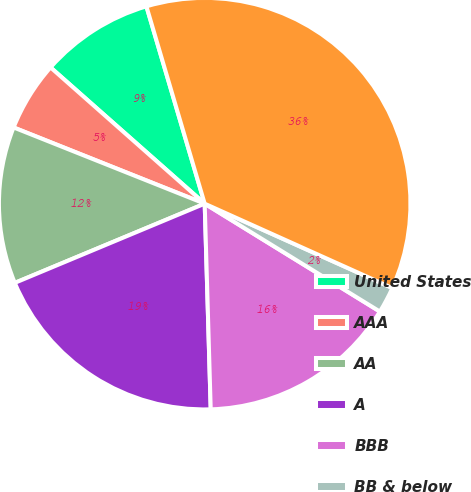Convert chart to OTSL. <chart><loc_0><loc_0><loc_500><loc_500><pie_chart><fcel>United States<fcel>AAA<fcel>AA<fcel>A<fcel>BBB<fcel>BB & below<fcel>Total fixed maturities AFS<nl><fcel>8.91%<fcel>5.48%<fcel>12.33%<fcel>19.18%<fcel>15.75%<fcel>2.06%<fcel>36.3%<nl></chart> 